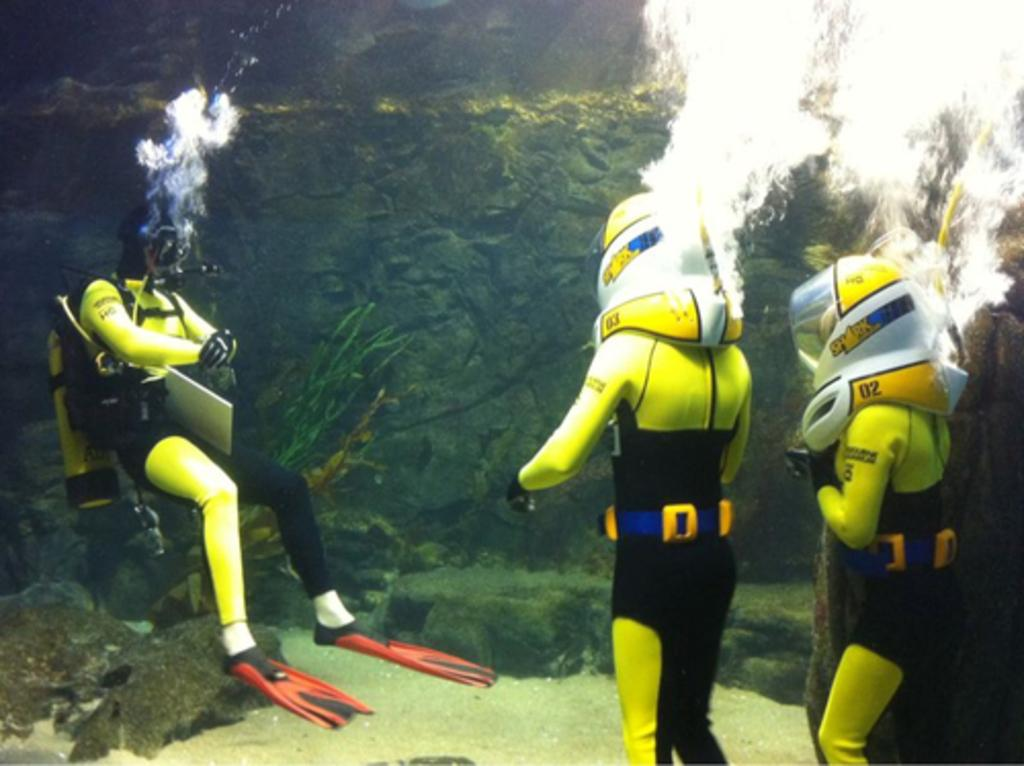<image>
Create a compact narrative representing the image presented. Three divers are in a tank and one has the number 02 on her helmet. 